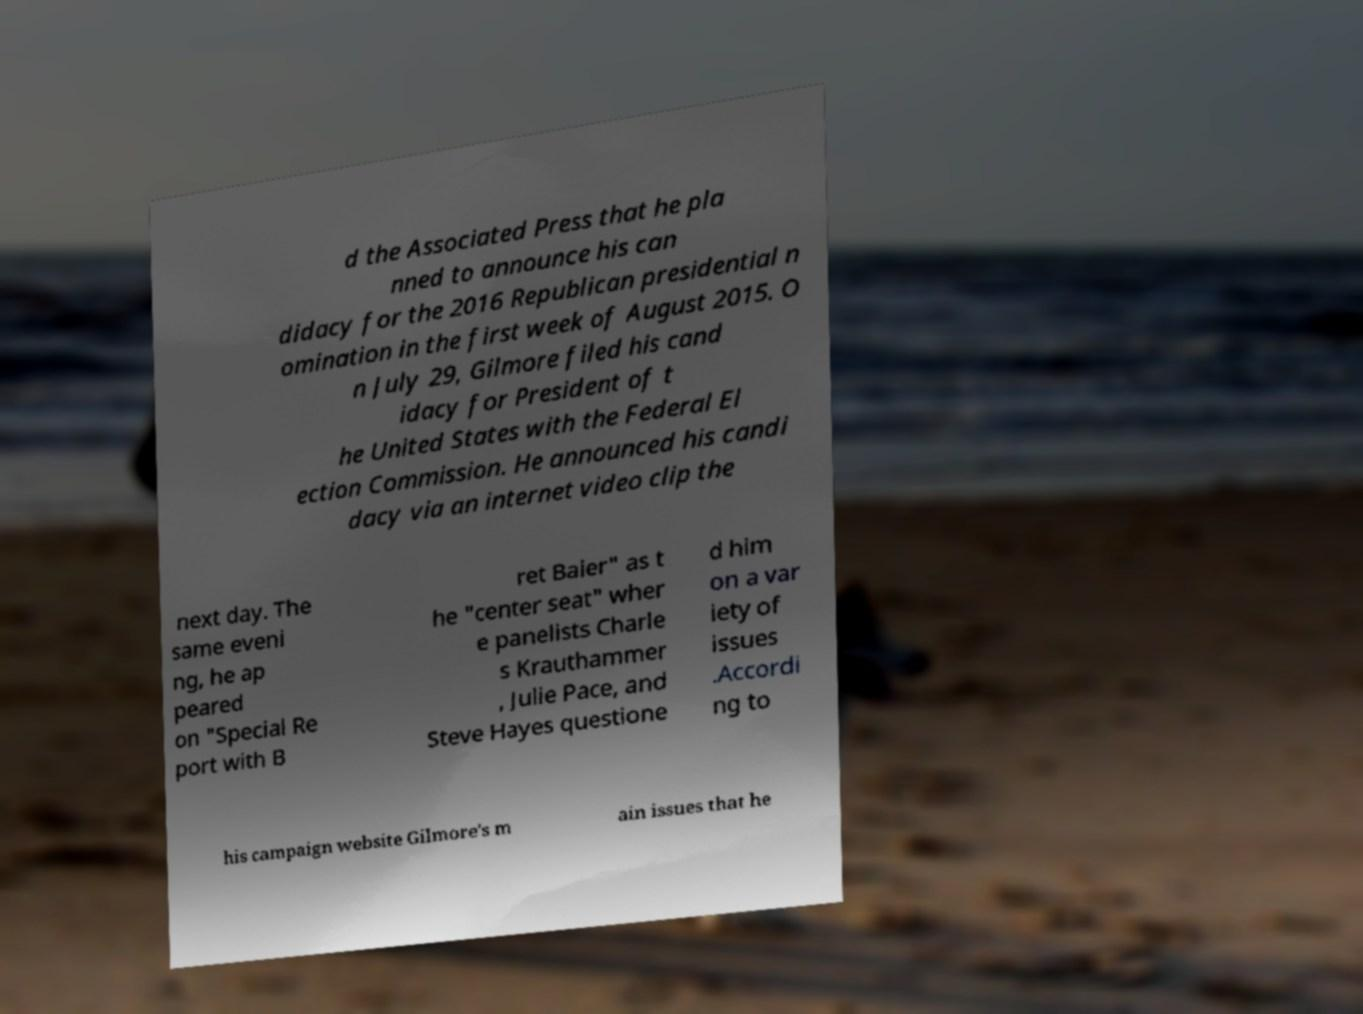Could you extract and type out the text from this image? d the Associated Press that he pla nned to announce his can didacy for the 2016 Republican presidential n omination in the first week of August 2015. O n July 29, Gilmore filed his cand idacy for President of t he United States with the Federal El ection Commission. He announced his candi dacy via an internet video clip the next day. The same eveni ng, he ap peared on "Special Re port with B ret Baier" as t he "center seat" wher e panelists Charle s Krauthammer , Julie Pace, and Steve Hayes questione d him on a var iety of issues .Accordi ng to his campaign website Gilmore's m ain issues that he 